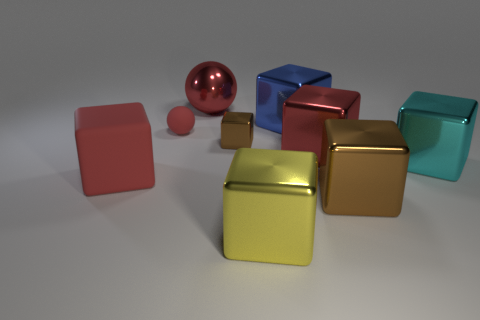Subtract all big brown metallic cubes. How many cubes are left? 6 Subtract 2 cubes. How many cubes are left? 5 Subtract all yellow cubes. How many cubes are left? 6 Subtract all blue blocks. Subtract all gray cylinders. How many blocks are left? 6 Subtract all spheres. How many objects are left? 7 Subtract 0 blue cylinders. How many objects are left? 9 Subtract all yellow metal objects. Subtract all red rubber balls. How many objects are left? 7 Add 2 metallic cubes. How many metallic cubes are left? 8 Add 6 big green things. How many big green things exist? 6 